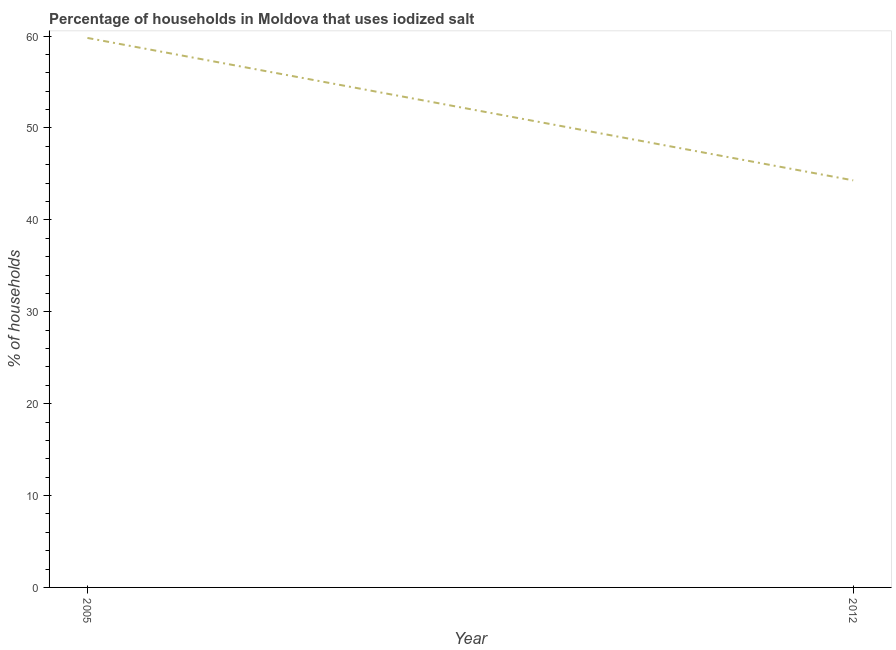What is the percentage of households where iodized salt is consumed in 2012?
Provide a succinct answer. 44.3. Across all years, what is the maximum percentage of households where iodized salt is consumed?
Keep it short and to the point. 59.8. Across all years, what is the minimum percentage of households where iodized salt is consumed?
Give a very brief answer. 44.3. What is the sum of the percentage of households where iodized salt is consumed?
Your answer should be very brief. 104.1. What is the difference between the percentage of households where iodized salt is consumed in 2005 and 2012?
Your response must be concise. 15.5. What is the average percentage of households where iodized salt is consumed per year?
Your response must be concise. 52.05. What is the median percentage of households where iodized salt is consumed?
Your answer should be compact. 52.05. In how many years, is the percentage of households where iodized salt is consumed greater than 48 %?
Provide a short and direct response. 1. What is the ratio of the percentage of households where iodized salt is consumed in 2005 to that in 2012?
Provide a short and direct response. 1.35. In how many years, is the percentage of households where iodized salt is consumed greater than the average percentage of households where iodized salt is consumed taken over all years?
Give a very brief answer. 1. How many lines are there?
Offer a terse response. 1. Does the graph contain any zero values?
Your answer should be very brief. No. What is the title of the graph?
Your answer should be compact. Percentage of households in Moldova that uses iodized salt. What is the label or title of the Y-axis?
Make the answer very short. % of households. What is the % of households in 2005?
Provide a succinct answer. 59.8. What is the % of households of 2012?
Ensure brevity in your answer.  44.3. What is the ratio of the % of households in 2005 to that in 2012?
Offer a very short reply. 1.35. 